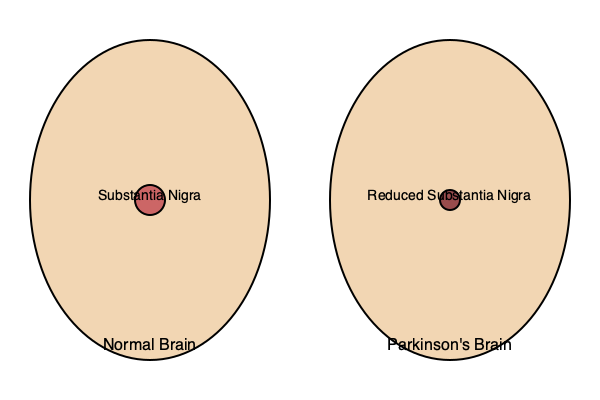Based on the visual comparison of a normal brain structure versus one affected by Parkinson's disease, what is the primary difference observed in the substantia nigra region? 1. The image shows two brain diagrams: a normal brain on the left and a brain affected by Parkinson's disease on the right.

2. In the normal brain, the substantia nigra is represented by a larger, darker circle in the center of the brain structure.

3. In the Parkinson's disease-affected brain, the substantia nigra is visibly smaller and lighter in color.

4. This difference illustrates the key pathological change in Parkinson's disease: the degeneration of dopamine-producing neurons in the substantia nigra.

5. The reduction in size and density of the substantia nigra leads to a decrease in dopamine production, which is responsible for many of the motor symptoms associated with Parkinson's disease.

6. This visual representation helps to understand why Parkinson's disease patients experience symptoms such as tremors, rigidity, and bradykinesia (slowness of movement).
Answer: Reduced size and density of substantia nigra 